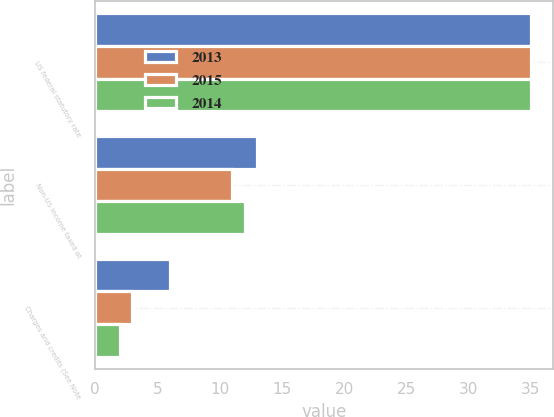Convert chart. <chart><loc_0><loc_0><loc_500><loc_500><stacked_bar_chart><ecel><fcel>US federal statutory rate<fcel>Non-US income taxed at<fcel>Charges and credits (See Note<nl><fcel>2013<fcel>35<fcel>13<fcel>6<nl><fcel>2015<fcel>35<fcel>11<fcel>3<nl><fcel>2014<fcel>35<fcel>12<fcel>2<nl></chart> 